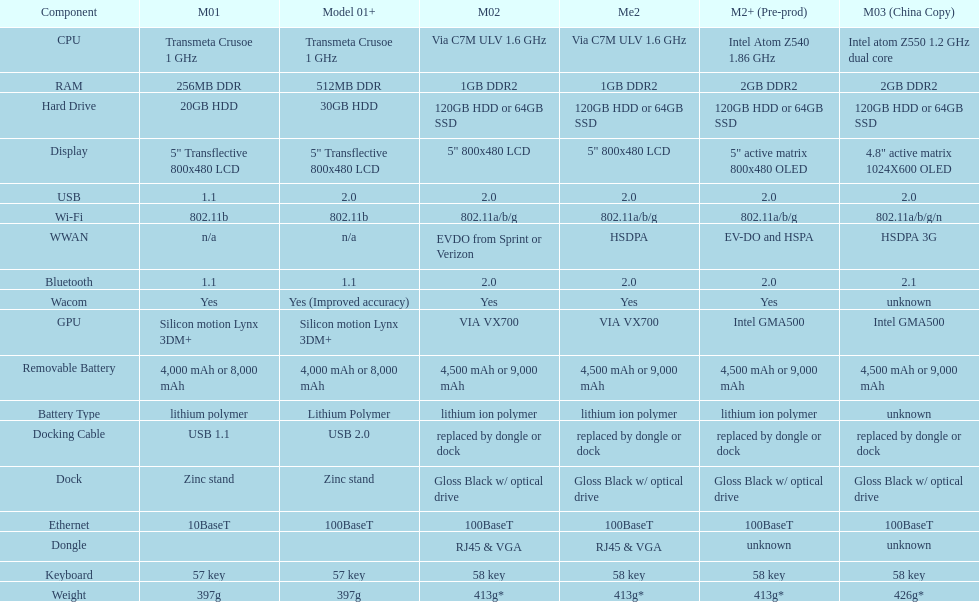What is the next highest hard drive available after the 30gb model? 64GB SSD. 